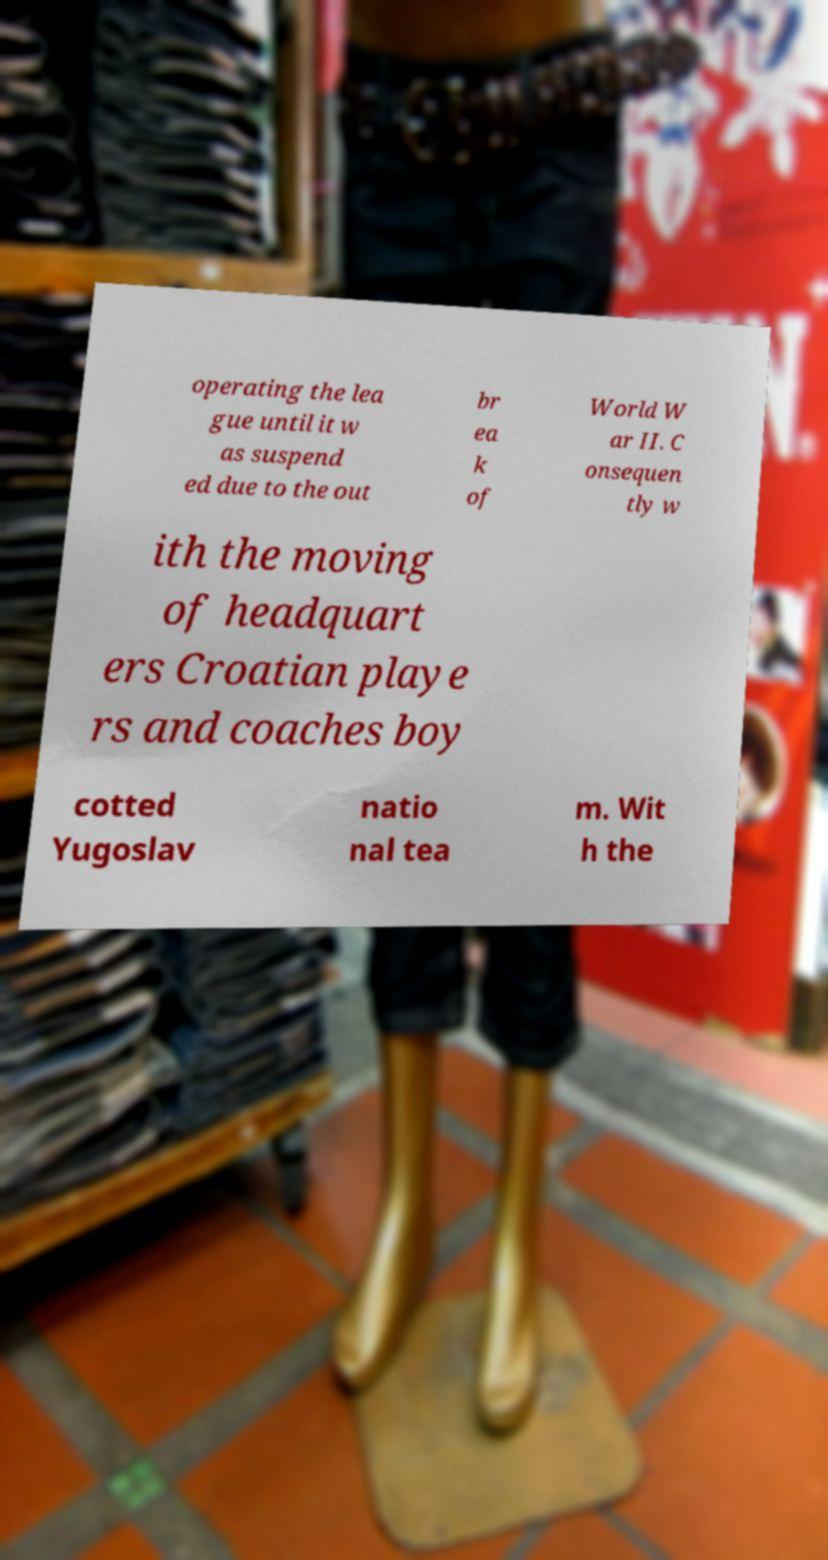There's text embedded in this image that I need extracted. Can you transcribe it verbatim? operating the lea gue until it w as suspend ed due to the out br ea k of World W ar II. C onsequen tly w ith the moving of headquart ers Croatian playe rs and coaches boy cotted Yugoslav natio nal tea m. Wit h the 